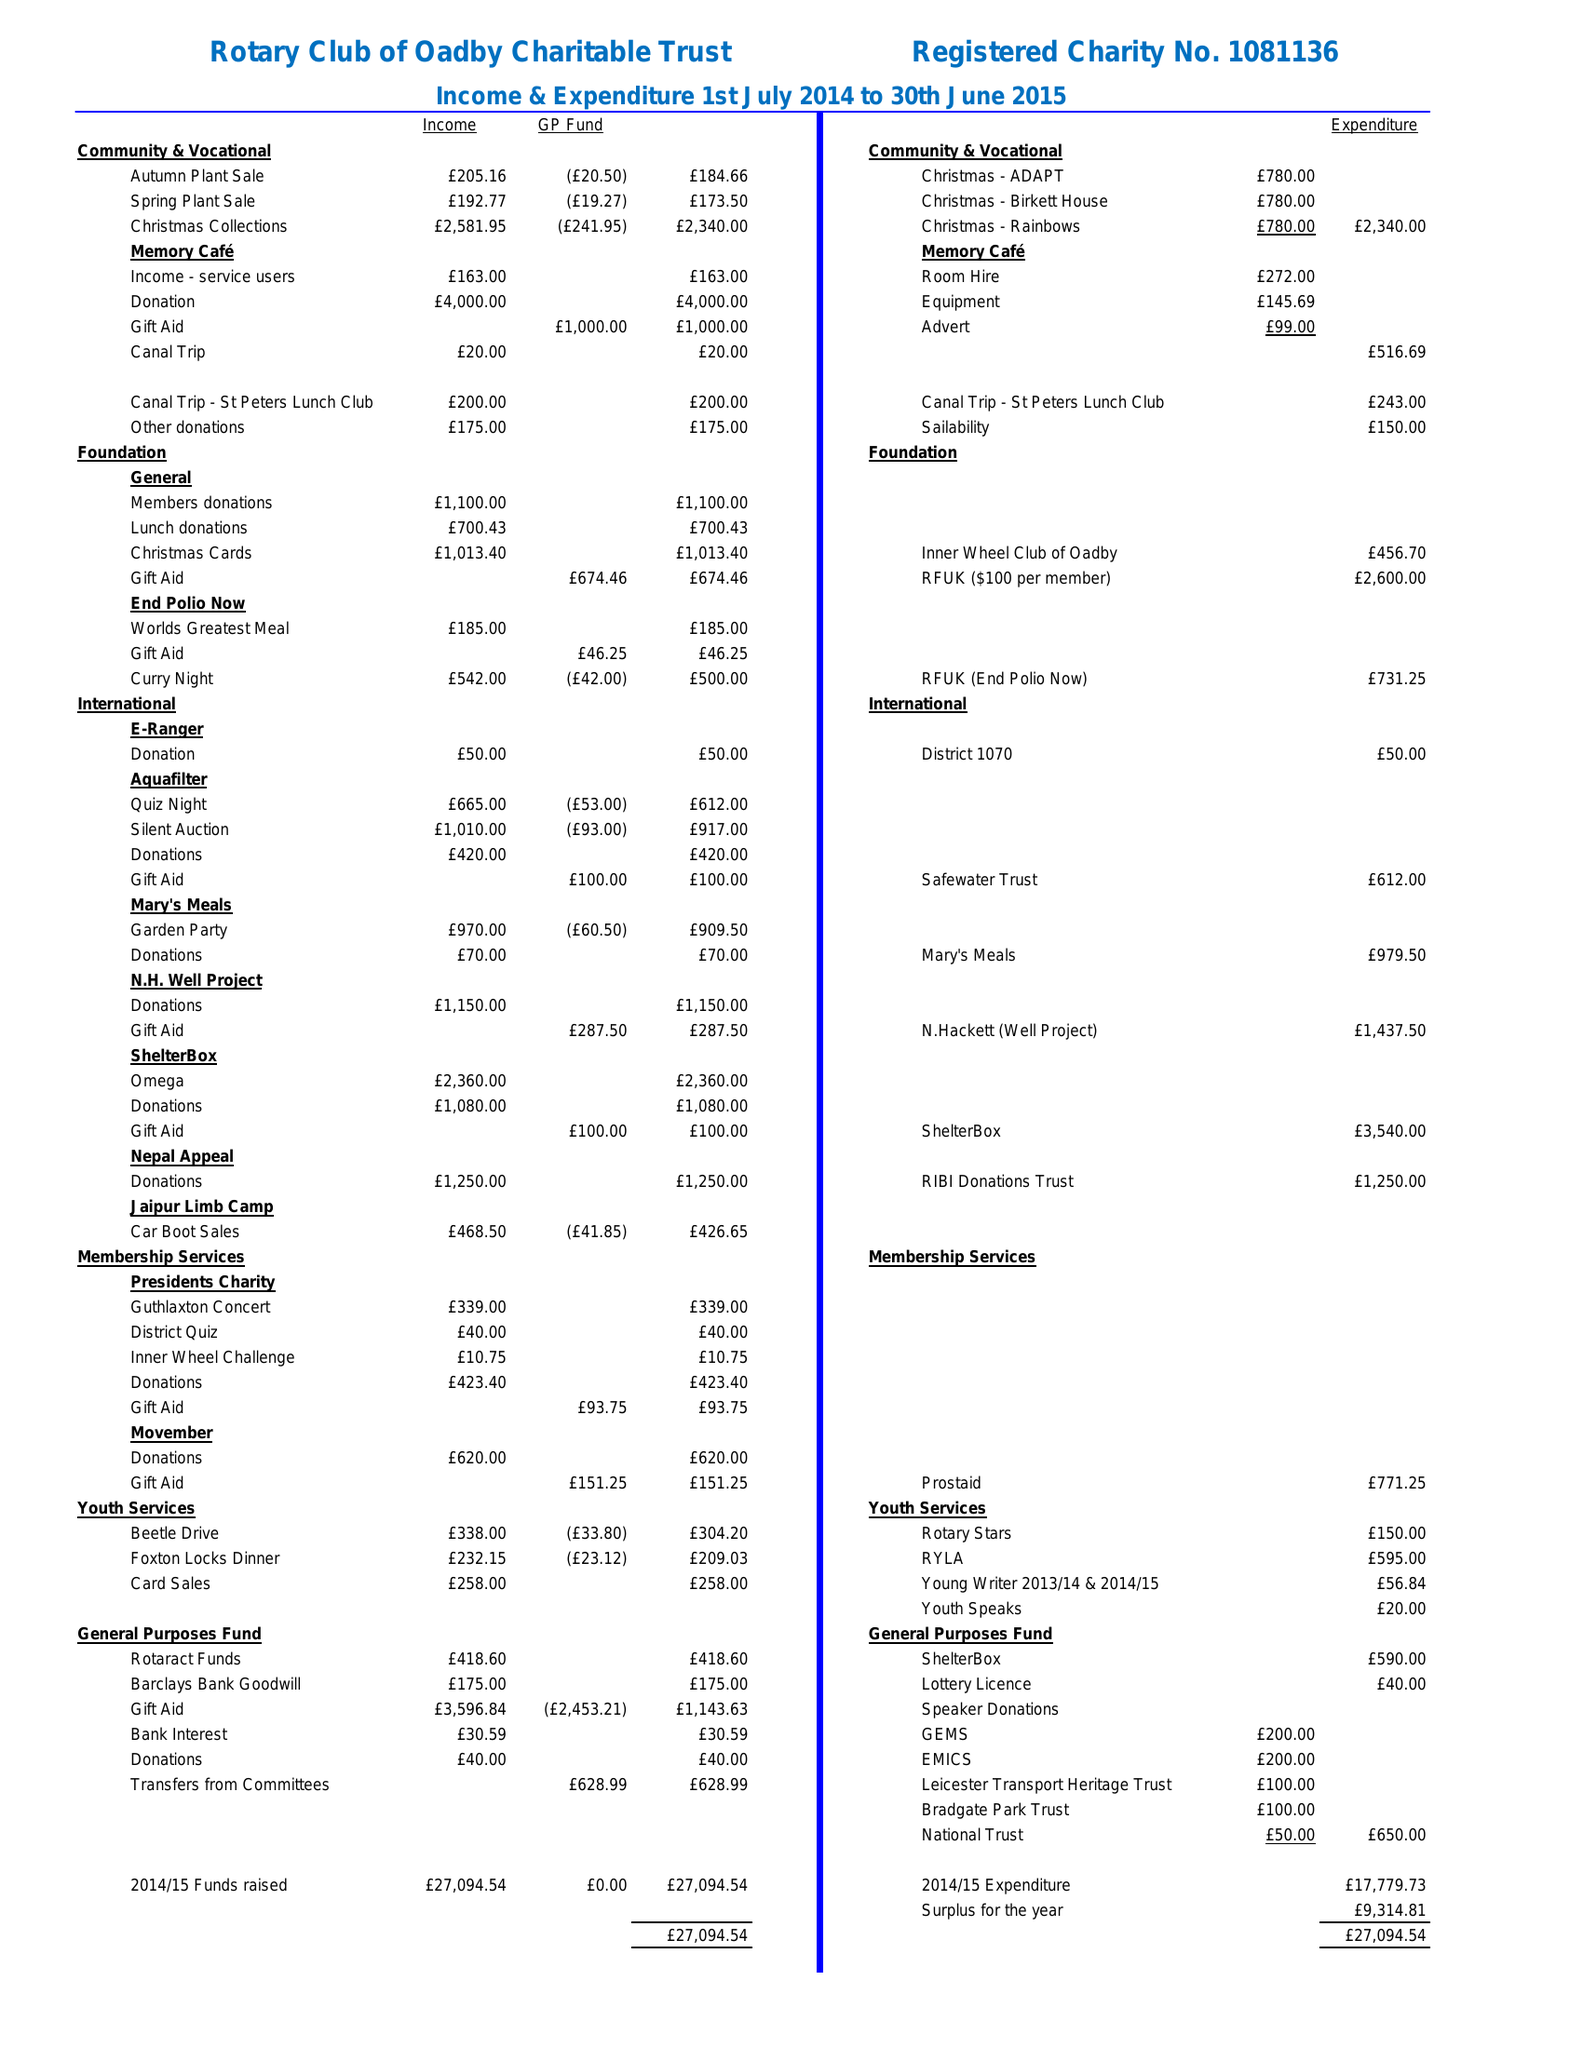What is the value for the address__post_town?
Answer the question using a single word or phrase. LEICESTER 